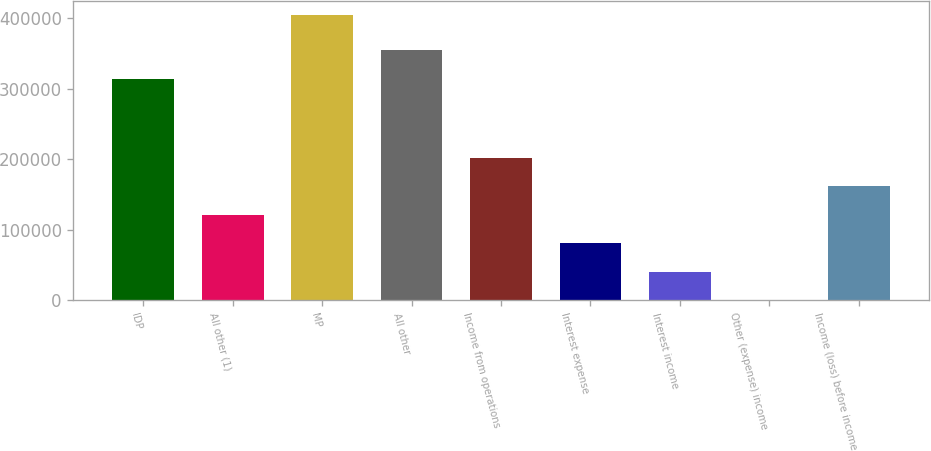<chart> <loc_0><loc_0><loc_500><loc_500><bar_chart><fcel>IDP<fcel>All other (1)<fcel>MP<fcel>All other<fcel>Income from operations<fcel>Interest expense<fcel>Interest income<fcel>Other (expense) income<fcel>Income (loss) before income<nl><fcel>313274<fcel>121492<fcel>404382<fcel>354178<fcel>202318<fcel>81079.6<fcel>40666.8<fcel>254<fcel>161905<nl></chart> 